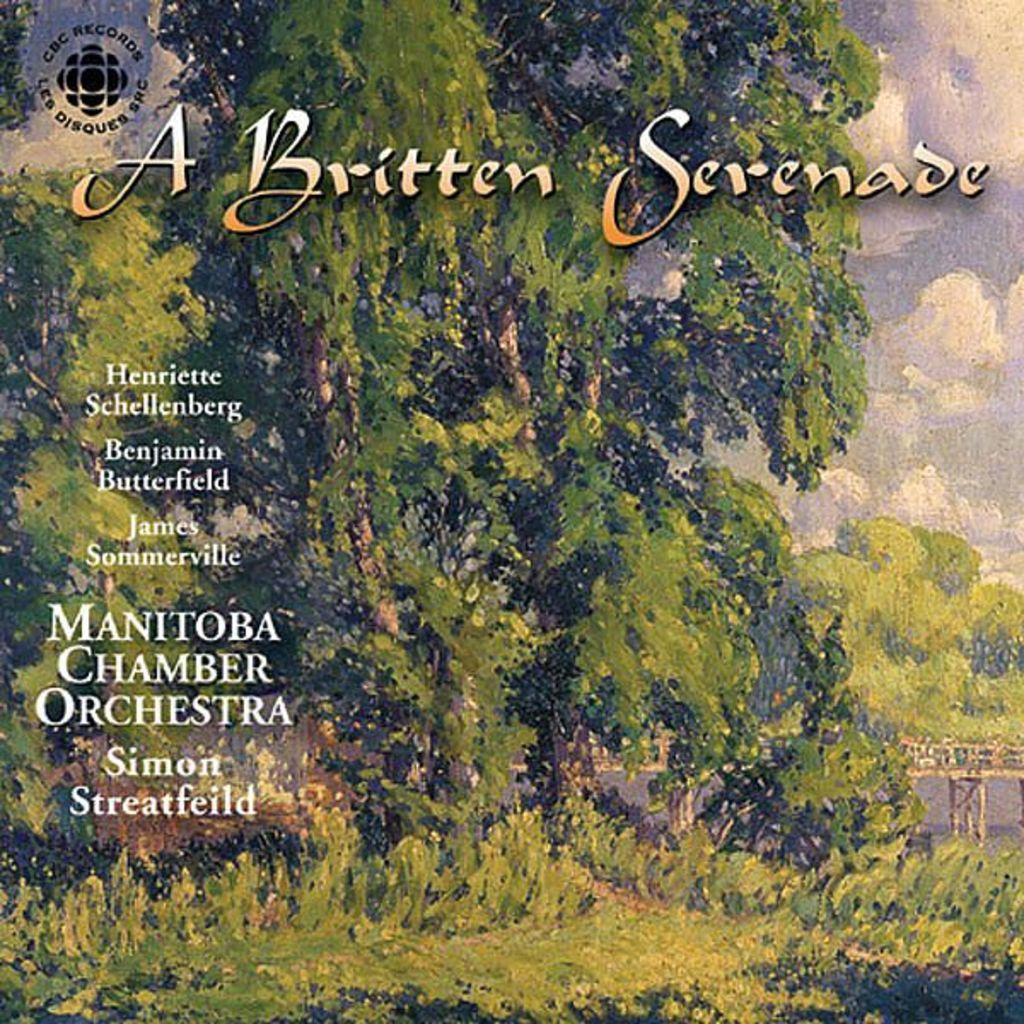Could you give a brief overview of what you see in this image? We can see poster,on this poster we can see trees,some text and sky with clouds. 